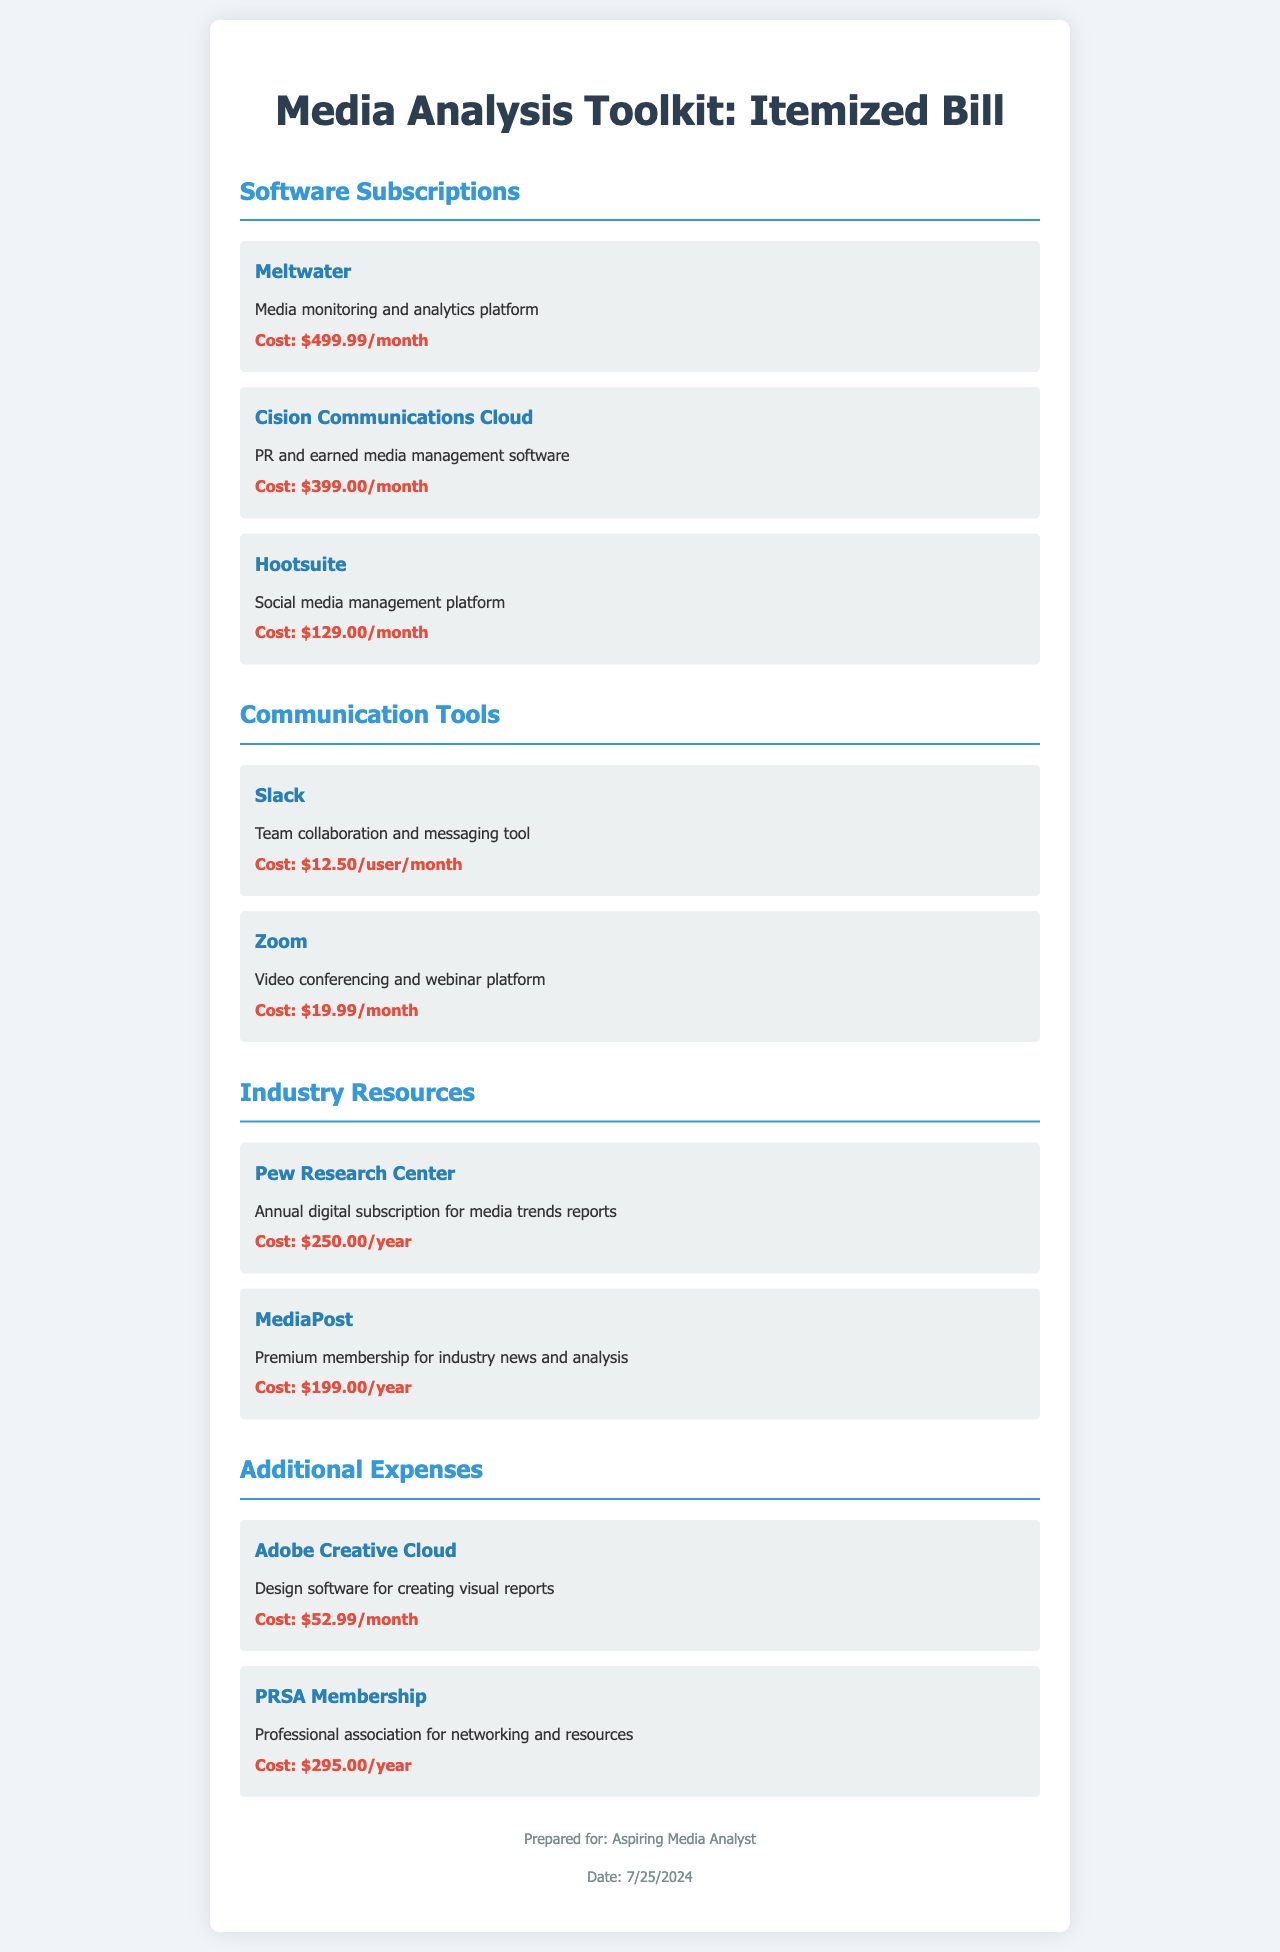What is the cost of Meltwater? The cost of Meltwater is explicitly stated in the document.
Answer: $499.99/month What communication tool costs $19.99 per month? The document lists costs for all communication tools, and Zoom is one of them.
Answer: Zoom How many software subscriptions are listed in the document? The document has individual sections, and the software subscriptions section has three listed items.
Answer: 3 Which industry resource has an annual cost of $199.00? The document specifies costs for resources, and MediaPost matches this cost.
Answer: MediaPost What membership costs $295.00 per year? The document clearly states the cost associated with PRSA Membership.
Answer: PRSA Membership If you subscribe to Hootsuite, how much will you pay per month? Hootsuite's monthly subscription cost is indicated in the document.
Answer: $129.00/month What is the total monthly cost of all software subscriptions? The total is the sum of all monthly software subscription costs presented in the document.
Answer: $1,080.99 Which tool is noted for team collaboration? The document describes Slack in its context as a team collaboration tool.
Answer: Slack How much does the Pew Research Center charge annually? The annual charge for the Pew Research Center is clearly mentioned.
Answer: $250.00/year 